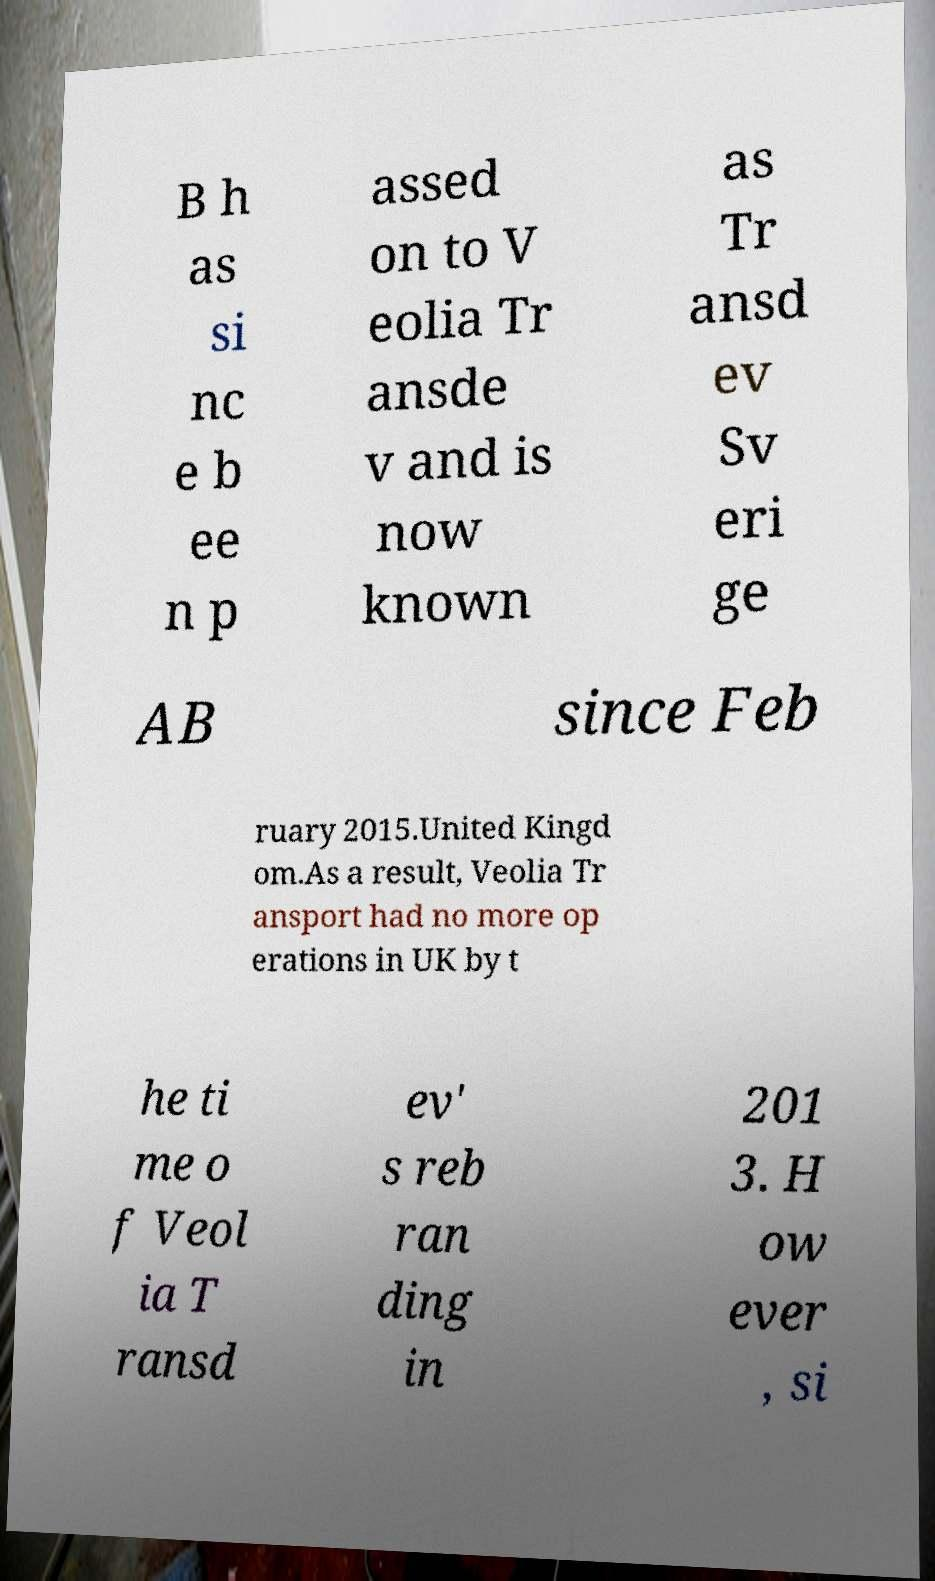What messages or text are displayed in this image? I need them in a readable, typed format. B h as si nc e b ee n p assed on to V eolia Tr ansde v and is now known as Tr ansd ev Sv eri ge AB since Feb ruary 2015.United Kingd om.As a result, Veolia Tr ansport had no more op erations in UK by t he ti me o f Veol ia T ransd ev' s reb ran ding in 201 3. H ow ever , si 